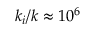Convert formula to latex. <formula><loc_0><loc_0><loc_500><loc_500>k _ { i } / k \approx 1 0 ^ { 6 }</formula> 